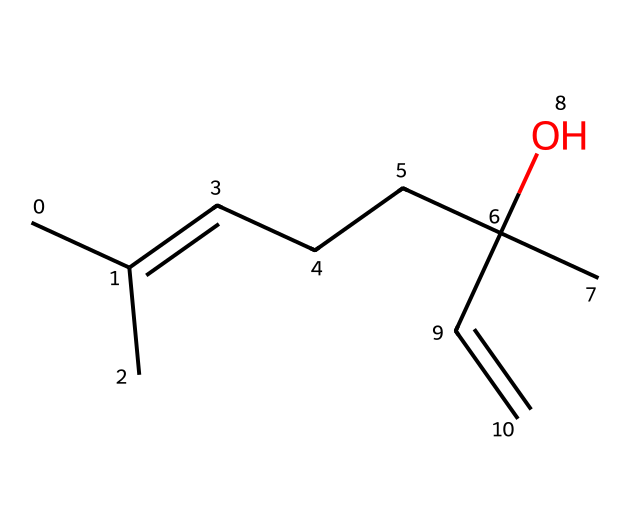What is the primary functional group in linalool? The presence of the hydroxyl group (OH) indicates that it is an alcohol, which is the primary functional group.
Answer: alcohol How many carbon atoms are in linalool? By examining the structural representation, there are 10 carbon atoms.
Answer: 10 How many double bonds are present in this structure? The structural formula shows one double bond between the two carbon atoms in the alkene portion of linalool.
Answer: 1 Is linalool saturated or unsaturated? The occurrence of a double bond indicates that linalool is unsaturated, as it contains less than the maximum number of hydrogen atoms.
Answer: unsaturated Which part of the chemical structure provides its floral aroma? The structure contains a specific arrangement of carbon and hydroxyl group that contributes to its characteristic floral scent, typical of many terpenes.
Answer: arrangement of carbon and hydroxyl group What type of terpene is linalool classified as? Linalool is classified as a monoterpene, which consists of two isoprene units, reflecting its molecular structure.
Answer: monoterpene 